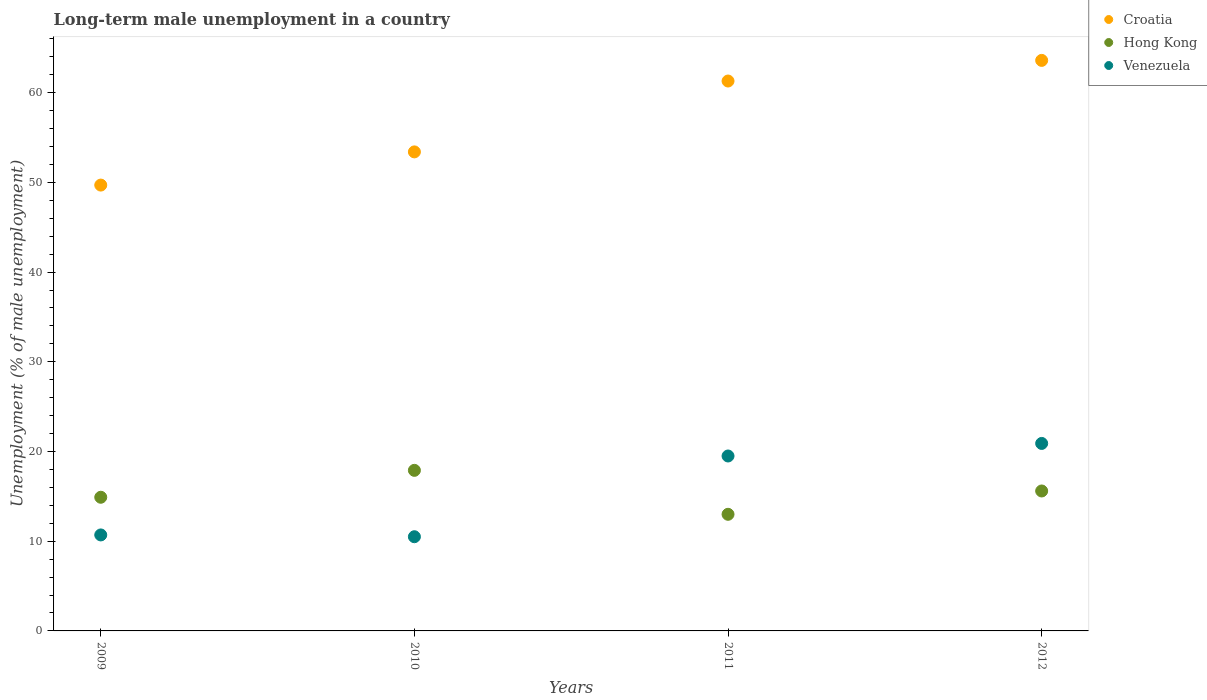What is the percentage of long-term unemployed male population in Venezuela in 2010?
Your answer should be very brief. 10.5. Across all years, what is the maximum percentage of long-term unemployed male population in Hong Kong?
Ensure brevity in your answer.  17.9. In which year was the percentage of long-term unemployed male population in Venezuela maximum?
Your response must be concise. 2012. What is the total percentage of long-term unemployed male population in Croatia in the graph?
Offer a terse response. 228. What is the difference between the percentage of long-term unemployed male population in Venezuela in 2009 and that in 2011?
Your response must be concise. -8.8. What is the difference between the percentage of long-term unemployed male population in Hong Kong in 2011 and the percentage of long-term unemployed male population in Croatia in 2012?
Your response must be concise. -50.6. What is the average percentage of long-term unemployed male population in Hong Kong per year?
Offer a terse response. 15.35. In the year 2010, what is the difference between the percentage of long-term unemployed male population in Hong Kong and percentage of long-term unemployed male population in Croatia?
Your response must be concise. -35.5. In how many years, is the percentage of long-term unemployed male population in Hong Kong greater than 28 %?
Your answer should be compact. 0. What is the ratio of the percentage of long-term unemployed male population in Hong Kong in 2010 to that in 2012?
Your answer should be compact. 1.15. What is the difference between the highest and the second highest percentage of long-term unemployed male population in Hong Kong?
Offer a terse response. 2.3. What is the difference between the highest and the lowest percentage of long-term unemployed male population in Croatia?
Offer a very short reply. 13.9. Is the sum of the percentage of long-term unemployed male population in Venezuela in 2010 and 2011 greater than the maximum percentage of long-term unemployed male population in Hong Kong across all years?
Provide a short and direct response. Yes. Does the percentage of long-term unemployed male population in Hong Kong monotonically increase over the years?
Provide a short and direct response. No. How many dotlines are there?
Give a very brief answer. 3. How many years are there in the graph?
Give a very brief answer. 4. Does the graph contain grids?
Provide a succinct answer. No. What is the title of the graph?
Provide a succinct answer. Long-term male unemployment in a country. What is the label or title of the X-axis?
Ensure brevity in your answer.  Years. What is the label or title of the Y-axis?
Provide a short and direct response. Unemployment (% of male unemployment). What is the Unemployment (% of male unemployment) of Croatia in 2009?
Make the answer very short. 49.7. What is the Unemployment (% of male unemployment) of Hong Kong in 2009?
Give a very brief answer. 14.9. What is the Unemployment (% of male unemployment) of Venezuela in 2009?
Give a very brief answer. 10.7. What is the Unemployment (% of male unemployment) in Croatia in 2010?
Provide a succinct answer. 53.4. What is the Unemployment (% of male unemployment) of Hong Kong in 2010?
Provide a short and direct response. 17.9. What is the Unemployment (% of male unemployment) in Croatia in 2011?
Provide a succinct answer. 61.3. What is the Unemployment (% of male unemployment) of Venezuela in 2011?
Your answer should be very brief. 19.5. What is the Unemployment (% of male unemployment) in Croatia in 2012?
Keep it short and to the point. 63.6. What is the Unemployment (% of male unemployment) in Hong Kong in 2012?
Your response must be concise. 15.6. What is the Unemployment (% of male unemployment) of Venezuela in 2012?
Provide a succinct answer. 20.9. Across all years, what is the maximum Unemployment (% of male unemployment) of Croatia?
Keep it short and to the point. 63.6. Across all years, what is the maximum Unemployment (% of male unemployment) in Hong Kong?
Your answer should be compact. 17.9. Across all years, what is the maximum Unemployment (% of male unemployment) in Venezuela?
Your answer should be very brief. 20.9. Across all years, what is the minimum Unemployment (% of male unemployment) in Croatia?
Keep it short and to the point. 49.7. Across all years, what is the minimum Unemployment (% of male unemployment) in Hong Kong?
Provide a succinct answer. 13. Across all years, what is the minimum Unemployment (% of male unemployment) of Venezuela?
Offer a terse response. 10.5. What is the total Unemployment (% of male unemployment) in Croatia in the graph?
Provide a short and direct response. 228. What is the total Unemployment (% of male unemployment) in Hong Kong in the graph?
Your answer should be very brief. 61.4. What is the total Unemployment (% of male unemployment) in Venezuela in the graph?
Make the answer very short. 61.6. What is the difference between the Unemployment (% of male unemployment) in Croatia in 2009 and that in 2010?
Your answer should be compact. -3.7. What is the difference between the Unemployment (% of male unemployment) in Hong Kong in 2009 and that in 2010?
Give a very brief answer. -3. What is the difference between the Unemployment (% of male unemployment) in Venezuela in 2009 and that in 2010?
Your answer should be compact. 0.2. What is the difference between the Unemployment (% of male unemployment) in Venezuela in 2009 and that in 2011?
Provide a succinct answer. -8.8. What is the difference between the Unemployment (% of male unemployment) in Hong Kong in 2009 and that in 2012?
Make the answer very short. -0.7. What is the difference between the Unemployment (% of male unemployment) in Venezuela in 2009 and that in 2012?
Your answer should be compact. -10.2. What is the difference between the Unemployment (% of male unemployment) of Croatia in 2010 and that in 2011?
Make the answer very short. -7.9. What is the difference between the Unemployment (% of male unemployment) of Hong Kong in 2010 and that in 2012?
Offer a terse response. 2.3. What is the difference between the Unemployment (% of male unemployment) in Venezuela in 2010 and that in 2012?
Give a very brief answer. -10.4. What is the difference between the Unemployment (% of male unemployment) in Venezuela in 2011 and that in 2012?
Provide a short and direct response. -1.4. What is the difference between the Unemployment (% of male unemployment) in Croatia in 2009 and the Unemployment (% of male unemployment) in Hong Kong in 2010?
Provide a short and direct response. 31.8. What is the difference between the Unemployment (% of male unemployment) of Croatia in 2009 and the Unemployment (% of male unemployment) of Venezuela in 2010?
Your answer should be very brief. 39.2. What is the difference between the Unemployment (% of male unemployment) of Hong Kong in 2009 and the Unemployment (% of male unemployment) of Venezuela in 2010?
Make the answer very short. 4.4. What is the difference between the Unemployment (% of male unemployment) in Croatia in 2009 and the Unemployment (% of male unemployment) in Hong Kong in 2011?
Your answer should be very brief. 36.7. What is the difference between the Unemployment (% of male unemployment) of Croatia in 2009 and the Unemployment (% of male unemployment) of Venezuela in 2011?
Make the answer very short. 30.2. What is the difference between the Unemployment (% of male unemployment) of Hong Kong in 2009 and the Unemployment (% of male unemployment) of Venezuela in 2011?
Give a very brief answer. -4.6. What is the difference between the Unemployment (% of male unemployment) of Croatia in 2009 and the Unemployment (% of male unemployment) of Hong Kong in 2012?
Provide a short and direct response. 34.1. What is the difference between the Unemployment (% of male unemployment) in Croatia in 2009 and the Unemployment (% of male unemployment) in Venezuela in 2012?
Offer a very short reply. 28.8. What is the difference between the Unemployment (% of male unemployment) in Hong Kong in 2009 and the Unemployment (% of male unemployment) in Venezuela in 2012?
Keep it short and to the point. -6. What is the difference between the Unemployment (% of male unemployment) of Croatia in 2010 and the Unemployment (% of male unemployment) of Hong Kong in 2011?
Make the answer very short. 40.4. What is the difference between the Unemployment (% of male unemployment) in Croatia in 2010 and the Unemployment (% of male unemployment) in Venezuela in 2011?
Your answer should be very brief. 33.9. What is the difference between the Unemployment (% of male unemployment) in Hong Kong in 2010 and the Unemployment (% of male unemployment) in Venezuela in 2011?
Keep it short and to the point. -1.6. What is the difference between the Unemployment (% of male unemployment) in Croatia in 2010 and the Unemployment (% of male unemployment) in Hong Kong in 2012?
Your answer should be very brief. 37.8. What is the difference between the Unemployment (% of male unemployment) of Croatia in 2010 and the Unemployment (% of male unemployment) of Venezuela in 2012?
Your answer should be compact. 32.5. What is the difference between the Unemployment (% of male unemployment) of Hong Kong in 2010 and the Unemployment (% of male unemployment) of Venezuela in 2012?
Make the answer very short. -3. What is the difference between the Unemployment (% of male unemployment) of Croatia in 2011 and the Unemployment (% of male unemployment) of Hong Kong in 2012?
Your answer should be compact. 45.7. What is the difference between the Unemployment (% of male unemployment) of Croatia in 2011 and the Unemployment (% of male unemployment) of Venezuela in 2012?
Give a very brief answer. 40.4. What is the average Unemployment (% of male unemployment) of Hong Kong per year?
Make the answer very short. 15.35. What is the average Unemployment (% of male unemployment) of Venezuela per year?
Provide a short and direct response. 15.4. In the year 2009, what is the difference between the Unemployment (% of male unemployment) in Croatia and Unemployment (% of male unemployment) in Hong Kong?
Ensure brevity in your answer.  34.8. In the year 2009, what is the difference between the Unemployment (% of male unemployment) of Hong Kong and Unemployment (% of male unemployment) of Venezuela?
Make the answer very short. 4.2. In the year 2010, what is the difference between the Unemployment (% of male unemployment) in Croatia and Unemployment (% of male unemployment) in Hong Kong?
Offer a terse response. 35.5. In the year 2010, what is the difference between the Unemployment (% of male unemployment) in Croatia and Unemployment (% of male unemployment) in Venezuela?
Your answer should be compact. 42.9. In the year 2010, what is the difference between the Unemployment (% of male unemployment) of Hong Kong and Unemployment (% of male unemployment) of Venezuela?
Offer a terse response. 7.4. In the year 2011, what is the difference between the Unemployment (% of male unemployment) in Croatia and Unemployment (% of male unemployment) in Hong Kong?
Give a very brief answer. 48.3. In the year 2011, what is the difference between the Unemployment (% of male unemployment) of Croatia and Unemployment (% of male unemployment) of Venezuela?
Your answer should be very brief. 41.8. In the year 2012, what is the difference between the Unemployment (% of male unemployment) of Croatia and Unemployment (% of male unemployment) of Hong Kong?
Ensure brevity in your answer.  48. In the year 2012, what is the difference between the Unemployment (% of male unemployment) of Croatia and Unemployment (% of male unemployment) of Venezuela?
Provide a short and direct response. 42.7. In the year 2012, what is the difference between the Unemployment (% of male unemployment) of Hong Kong and Unemployment (% of male unemployment) of Venezuela?
Provide a succinct answer. -5.3. What is the ratio of the Unemployment (% of male unemployment) in Croatia in 2009 to that in 2010?
Your response must be concise. 0.93. What is the ratio of the Unemployment (% of male unemployment) of Hong Kong in 2009 to that in 2010?
Your answer should be compact. 0.83. What is the ratio of the Unemployment (% of male unemployment) of Venezuela in 2009 to that in 2010?
Provide a short and direct response. 1.02. What is the ratio of the Unemployment (% of male unemployment) in Croatia in 2009 to that in 2011?
Give a very brief answer. 0.81. What is the ratio of the Unemployment (% of male unemployment) in Hong Kong in 2009 to that in 2011?
Give a very brief answer. 1.15. What is the ratio of the Unemployment (% of male unemployment) of Venezuela in 2009 to that in 2011?
Provide a succinct answer. 0.55. What is the ratio of the Unemployment (% of male unemployment) in Croatia in 2009 to that in 2012?
Your answer should be compact. 0.78. What is the ratio of the Unemployment (% of male unemployment) of Hong Kong in 2009 to that in 2012?
Your answer should be very brief. 0.96. What is the ratio of the Unemployment (% of male unemployment) of Venezuela in 2009 to that in 2012?
Your response must be concise. 0.51. What is the ratio of the Unemployment (% of male unemployment) in Croatia in 2010 to that in 2011?
Give a very brief answer. 0.87. What is the ratio of the Unemployment (% of male unemployment) of Hong Kong in 2010 to that in 2011?
Make the answer very short. 1.38. What is the ratio of the Unemployment (% of male unemployment) of Venezuela in 2010 to that in 2011?
Offer a very short reply. 0.54. What is the ratio of the Unemployment (% of male unemployment) of Croatia in 2010 to that in 2012?
Your response must be concise. 0.84. What is the ratio of the Unemployment (% of male unemployment) in Hong Kong in 2010 to that in 2012?
Keep it short and to the point. 1.15. What is the ratio of the Unemployment (% of male unemployment) in Venezuela in 2010 to that in 2012?
Provide a succinct answer. 0.5. What is the ratio of the Unemployment (% of male unemployment) of Croatia in 2011 to that in 2012?
Your answer should be compact. 0.96. What is the ratio of the Unemployment (% of male unemployment) in Venezuela in 2011 to that in 2012?
Keep it short and to the point. 0.93. 